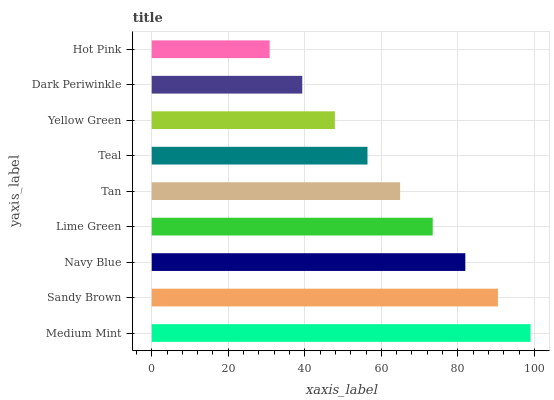Is Hot Pink the minimum?
Answer yes or no. Yes. Is Medium Mint the maximum?
Answer yes or no. Yes. Is Sandy Brown the minimum?
Answer yes or no. No. Is Sandy Brown the maximum?
Answer yes or no. No. Is Medium Mint greater than Sandy Brown?
Answer yes or no. Yes. Is Sandy Brown less than Medium Mint?
Answer yes or no. Yes. Is Sandy Brown greater than Medium Mint?
Answer yes or no. No. Is Medium Mint less than Sandy Brown?
Answer yes or no. No. Is Tan the high median?
Answer yes or no. Yes. Is Tan the low median?
Answer yes or no. Yes. Is Navy Blue the high median?
Answer yes or no. No. Is Medium Mint the low median?
Answer yes or no. No. 